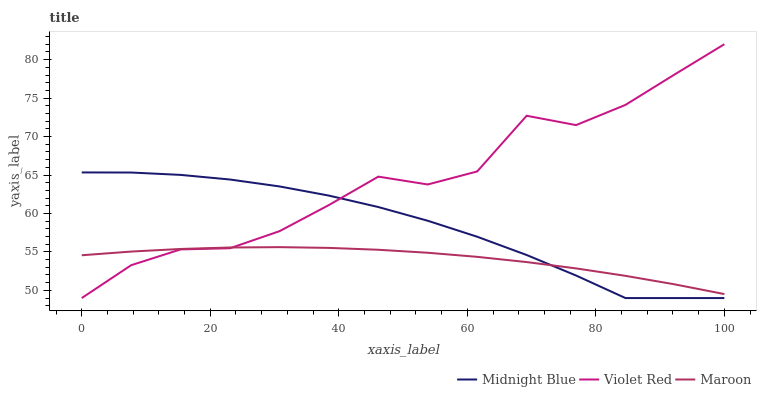Does Maroon have the minimum area under the curve?
Answer yes or no. Yes. Does Violet Red have the maximum area under the curve?
Answer yes or no. Yes. Does Midnight Blue have the minimum area under the curve?
Answer yes or no. No. Does Midnight Blue have the maximum area under the curve?
Answer yes or no. No. Is Maroon the smoothest?
Answer yes or no. Yes. Is Violet Red the roughest?
Answer yes or no. Yes. Is Midnight Blue the smoothest?
Answer yes or no. No. Is Midnight Blue the roughest?
Answer yes or no. No. Does Violet Red have the lowest value?
Answer yes or no. Yes. Does Maroon have the lowest value?
Answer yes or no. No. Does Violet Red have the highest value?
Answer yes or no. Yes. Does Midnight Blue have the highest value?
Answer yes or no. No. Does Violet Red intersect Midnight Blue?
Answer yes or no. Yes. Is Violet Red less than Midnight Blue?
Answer yes or no. No. Is Violet Red greater than Midnight Blue?
Answer yes or no. No. 